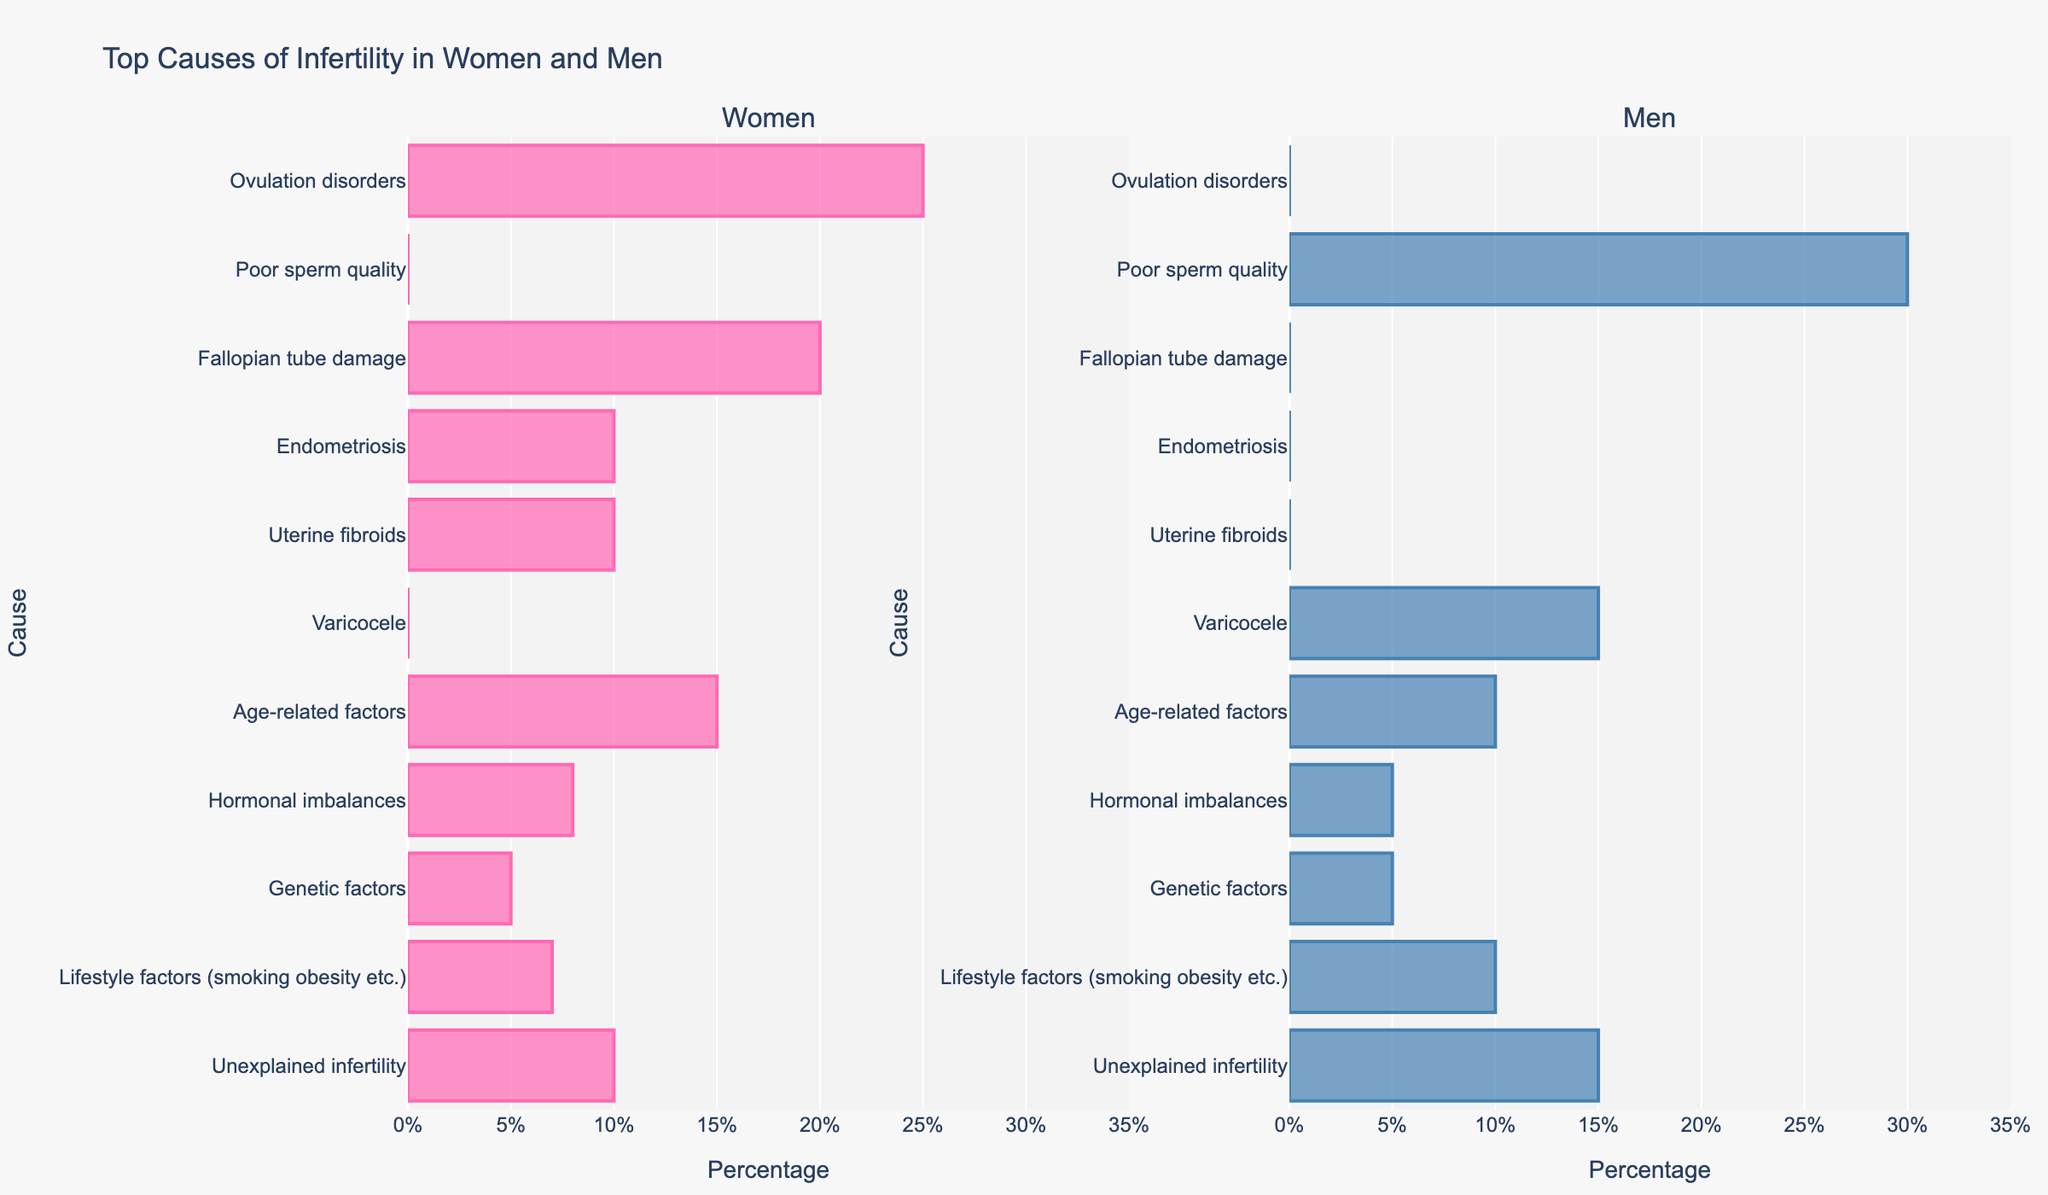What is the top cause of infertility in men and what is its percentage? The bar representing "Poor sperm quality" is the highest in the men's section. Its percentage is 30%.
Answer: Poor sperm quality, 30% What are the two most common causes of infertility in women, and their combined percentage? The two highest bars in the women's section are "Ovulation disorders" (25%) and "Fallopian tube damage" (20%). Their combined percentage is 25% + 20% = 45%.
Answer: Ovulation disorders and Fallopian tube damage, 45% Is "Unexplained infertility" more common in men or women and by how much? The bar for "Unexplained infertility" is higher in the men's section at 15% compared to 10% in the women's section. The difference is 15% - 10% = 5%.
Answer: Men, 5% Which cause of infertility has the same percentage for both men and women, and what is that percentage? By observing the figure, "Genetic factors" have the same height bars in both men and women sections, each at 5%.
Answer: Genetic factors, 5% By how much is the percentage of "Age-related factors" higher in women compared to men? The bar for "Age-related factors" is at 15% for women and 10% for men. The difference is 15% - 10% = 5%.
Answer: 5% How many causes of infertility in men have a percentage equal to or greater than 10%? By scanning through the men’s section, there are four bars with percentages 10% or more: "Poor sperm quality" (30%), "Varicocele" (15%), "Age-related factors" (10%), and "Unexplained infertility" (15%).
Answer: 4 What is the least common cause of infertility in women, and what is its percentage? The shortest bar in the women's section is for "Genetic factors" which stands at 5%.
Answer: Genetic factors, 5% Compare the percentages for hormonal imbalances in both men and women. The bar for "Hormonal imbalances" stands at 8% in women and 5% in men.
Answer: Women, 8%; Men, 5% What is the average percentage of all infertility causes in men? Sum of percentages in men: 30% (Poor sperm quality) + 15% (Varicocele) + 10% (Age-related factors) + 5% (Hormonal imbalances) + 5% (Genetic factors) + 10% (Lifestyle factors) + 15% (Unexplained infertility) = 90%. Number of causes = 7. Average = 90% / 7 ≈ 12.86%.
Answer: 12.86% What is the combined percentage of infertility causes in women that are related to structural issues (Fallopian tube damage, Endometriosis, Uterine fibroids)? Fallopian tube damage (20%) + Endometriosis (10%) + Uterine fibroids (10%) = 40%.
Answer: 40% 